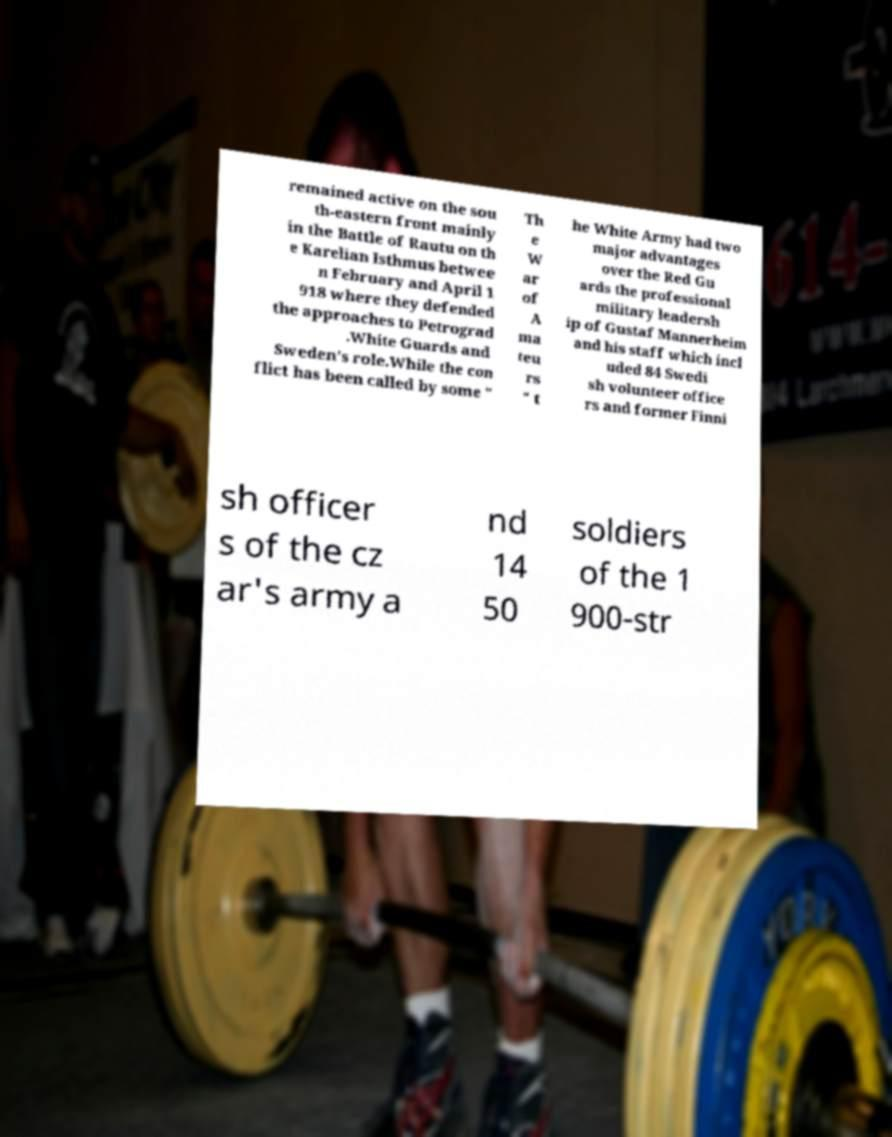For documentation purposes, I need the text within this image transcribed. Could you provide that? remained active on the sou th-eastern front mainly in the Battle of Rautu on th e Karelian Isthmus betwee n February and April 1 918 where they defended the approaches to Petrograd .White Guards and Sweden's role.While the con flict has been called by some " Th e W ar of A ma teu rs " t he White Army had two major advantages over the Red Gu ards the professional military leadersh ip of Gustaf Mannerheim and his staff which incl uded 84 Swedi sh volunteer office rs and former Finni sh officer s of the cz ar's army a nd 14 50 soldiers of the 1 900-str 